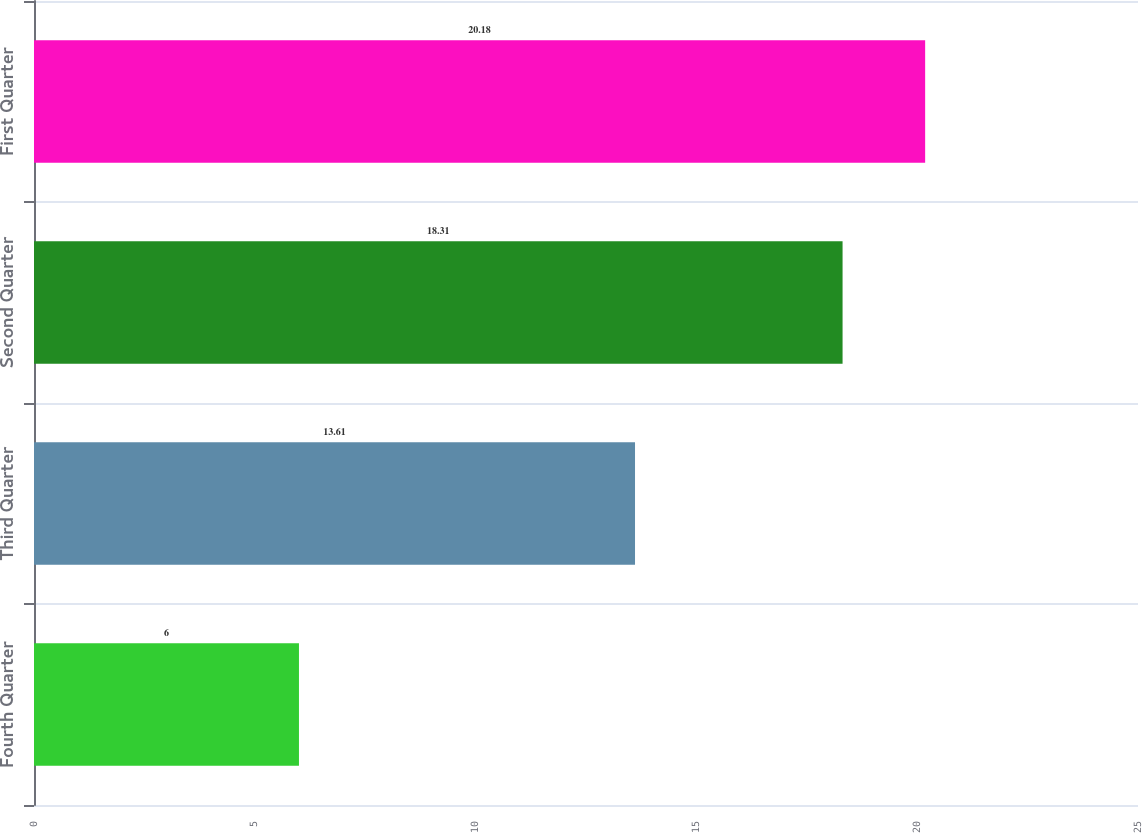<chart> <loc_0><loc_0><loc_500><loc_500><bar_chart><fcel>Fourth Quarter<fcel>Third Quarter<fcel>Second Quarter<fcel>First Quarter<nl><fcel>6<fcel>13.61<fcel>18.31<fcel>20.18<nl></chart> 